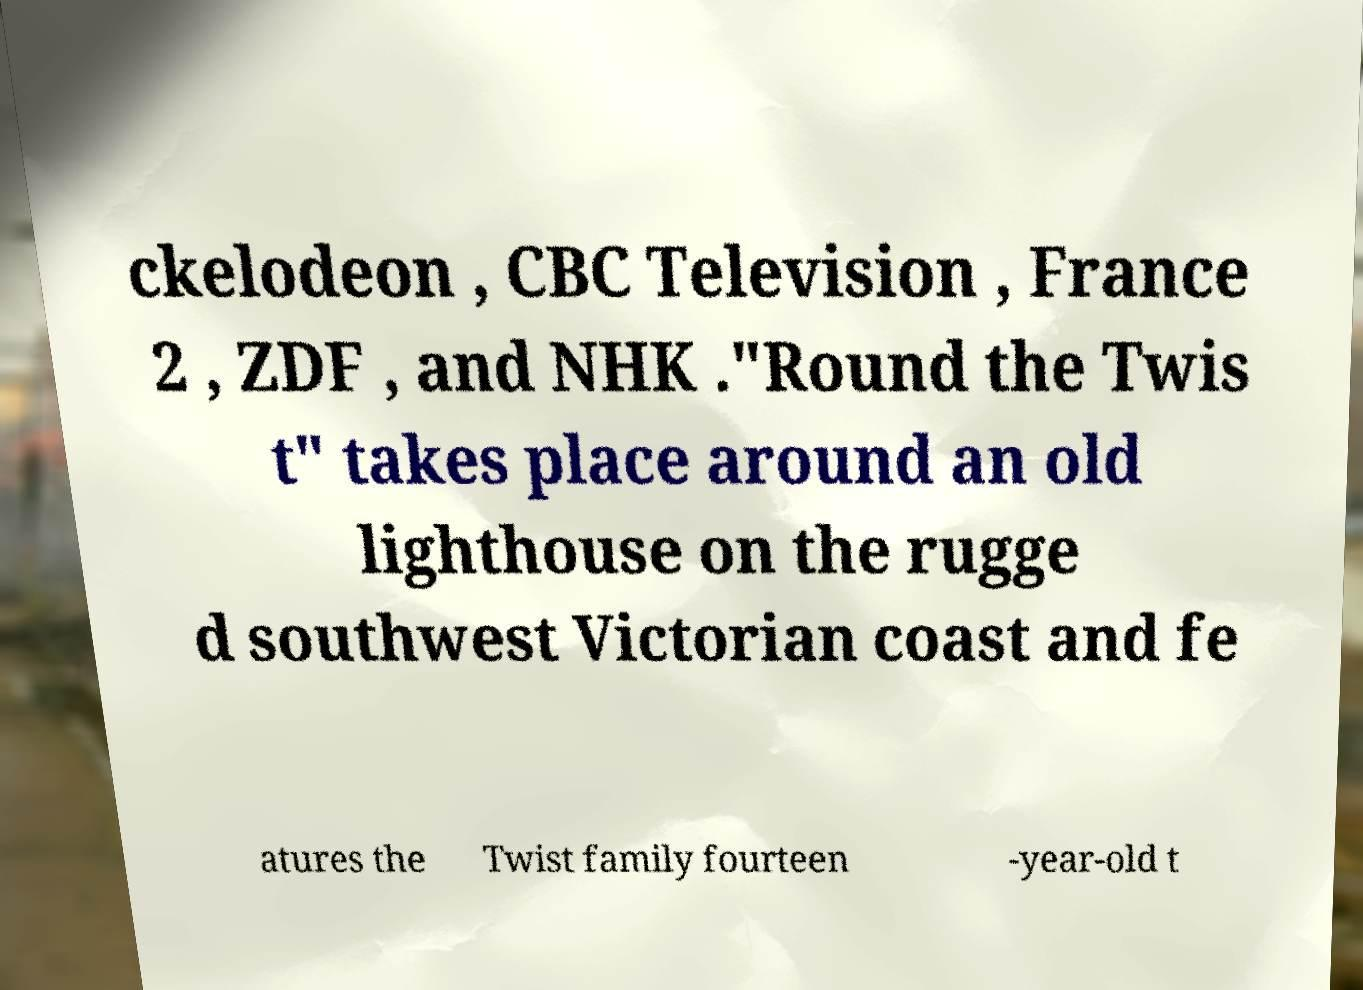I need the written content from this picture converted into text. Can you do that? ckelodeon , CBC Television , France 2 , ZDF , and NHK ."Round the Twis t" takes place around an old lighthouse on the rugge d southwest Victorian coast and fe atures the Twist family fourteen -year-old t 